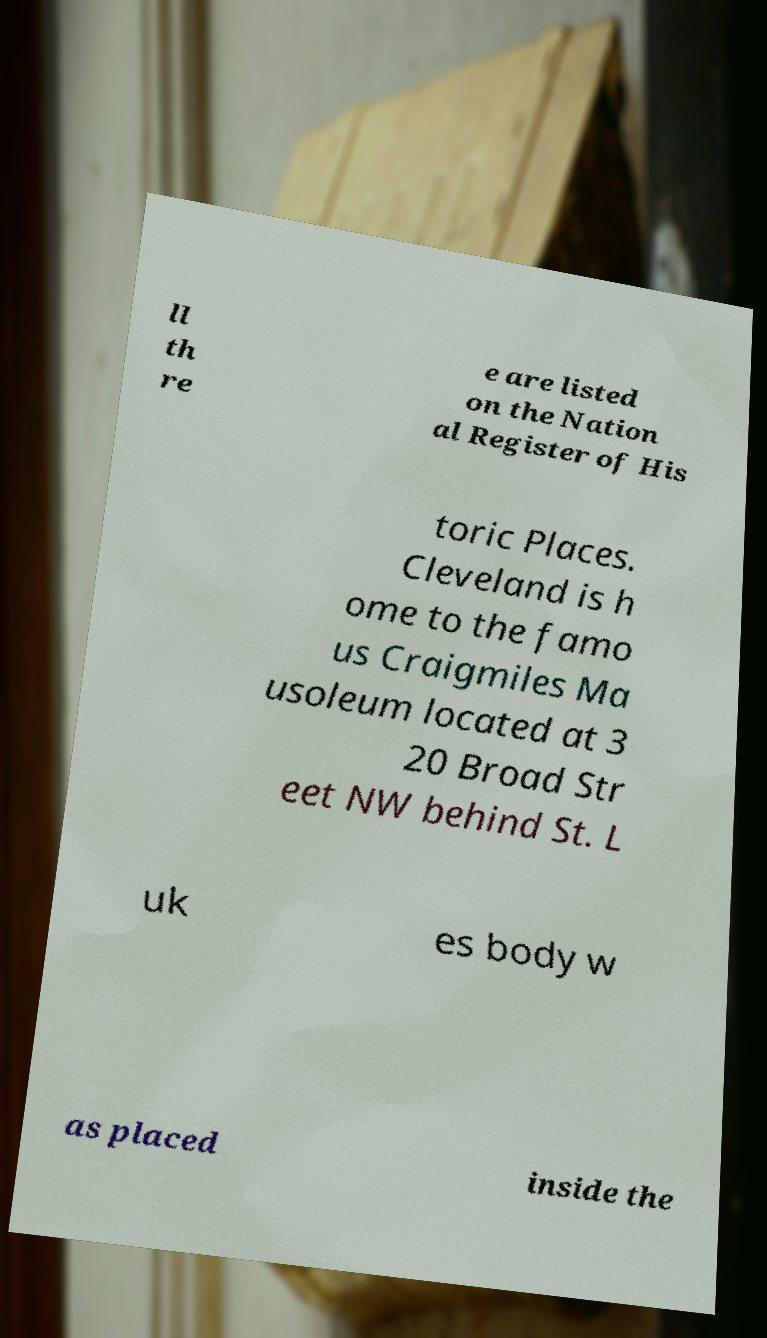What messages or text are displayed in this image? I need them in a readable, typed format. ll th re e are listed on the Nation al Register of His toric Places. Cleveland is h ome to the famo us Craigmiles Ma usoleum located at 3 20 Broad Str eet NW behind St. L uk es body w as placed inside the 